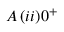Convert formula to latex. <formula><loc_0><loc_0><loc_500><loc_500>A \, ( i i ) 0 ^ { + }</formula> 